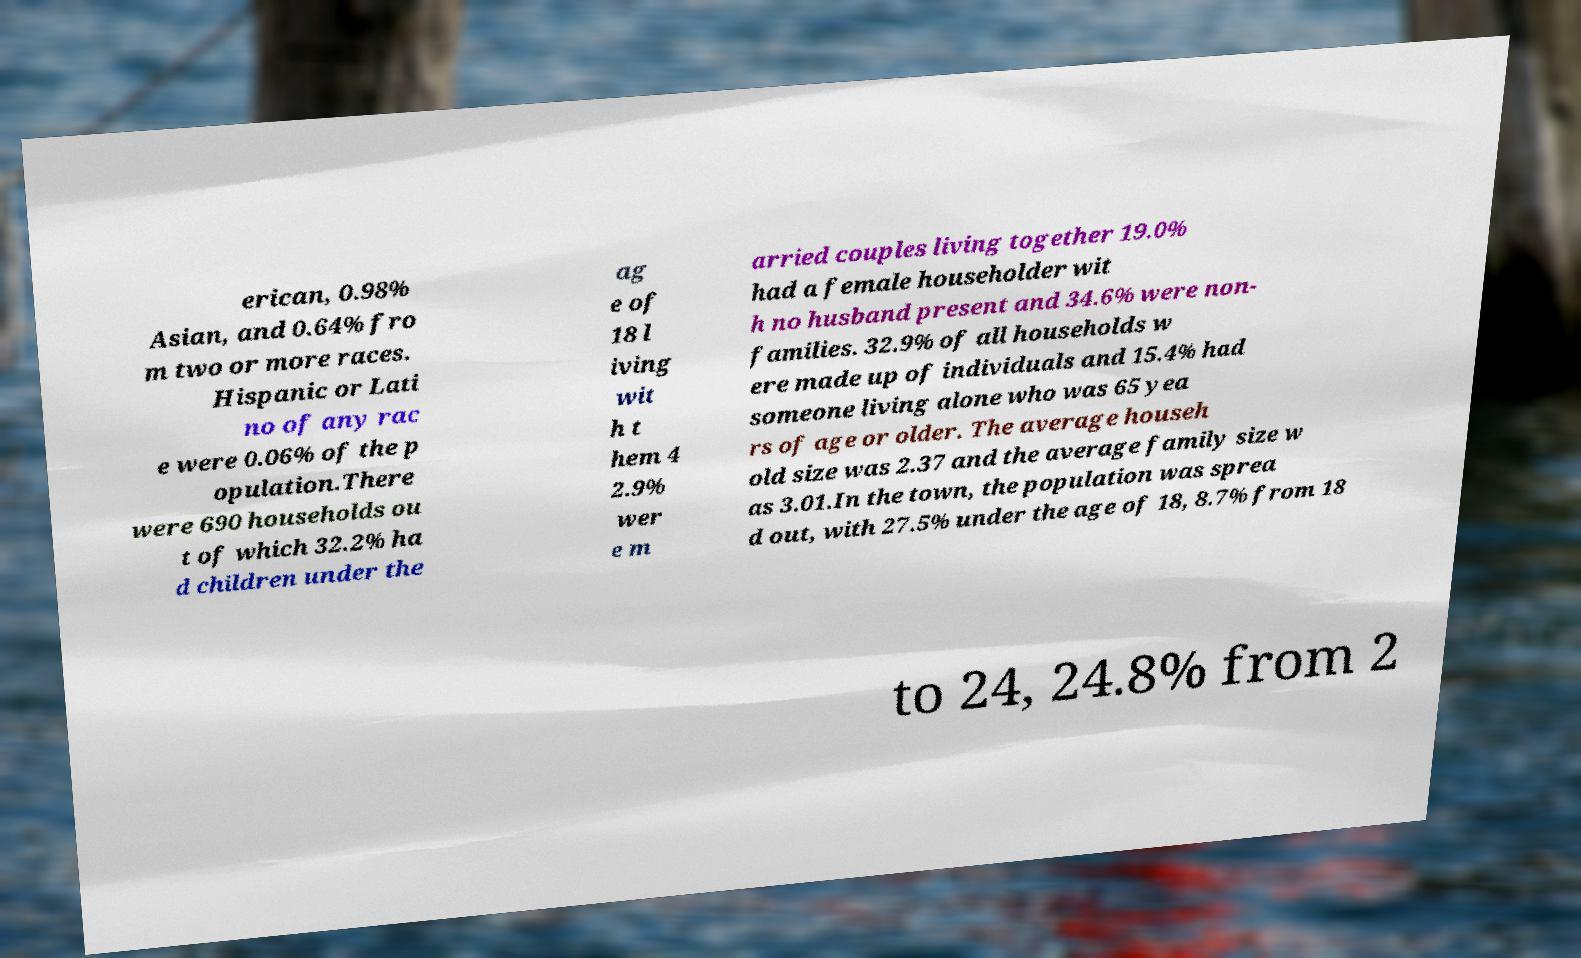Could you assist in decoding the text presented in this image and type it out clearly? erican, 0.98% Asian, and 0.64% fro m two or more races. Hispanic or Lati no of any rac e were 0.06% of the p opulation.There were 690 households ou t of which 32.2% ha d children under the ag e of 18 l iving wit h t hem 4 2.9% wer e m arried couples living together 19.0% had a female householder wit h no husband present and 34.6% were non- families. 32.9% of all households w ere made up of individuals and 15.4% had someone living alone who was 65 yea rs of age or older. The average househ old size was 2.37 and the average family size w as 3.01.In the town, the population was sprea d out, with 27.5% under the age of 18, 8.7% from 18 to 24, 24.8% from 2 